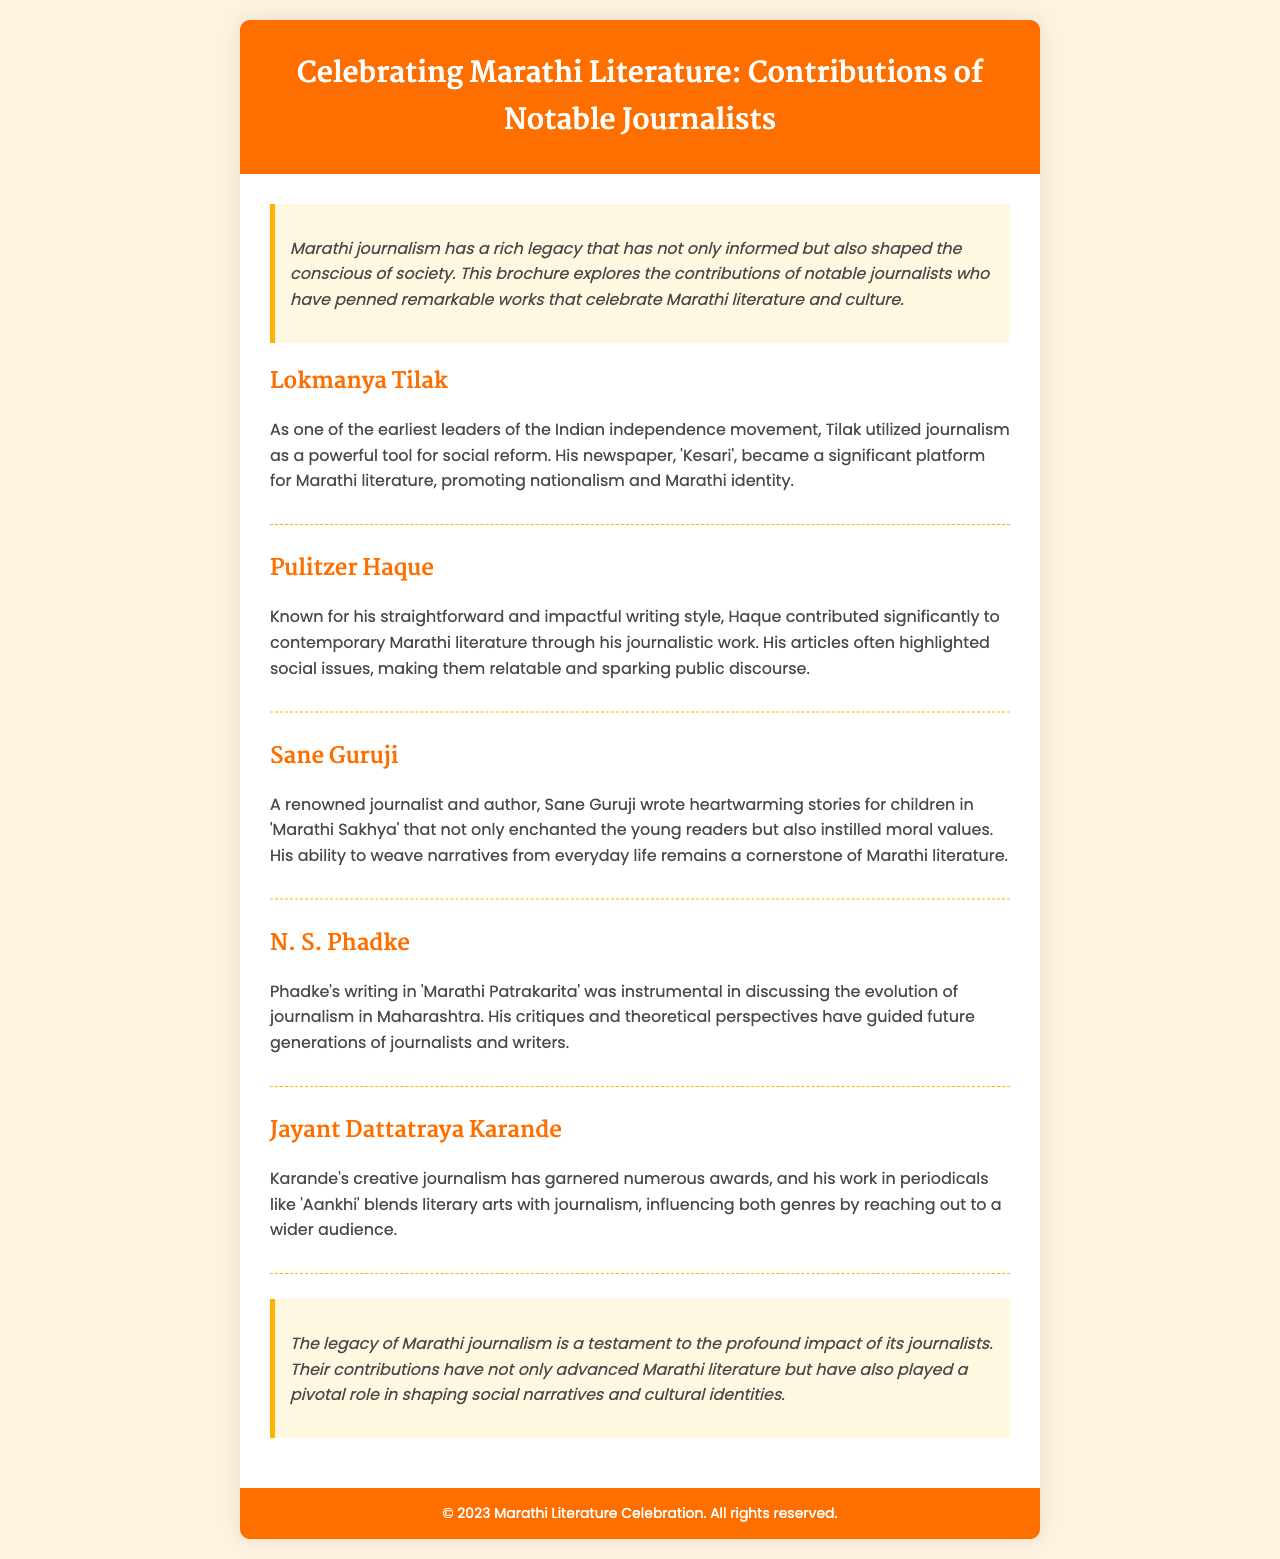What is the title of the brochure? The title is clearly mentioned at the top of the document.
Answer: Celebrating Marathi Literature: Contributions of Notable Journalists Who was the editor of the newspaper 'Kesari'? The document mentions Lokmanya Tilak as the editor of 'Kesari'.
Answer: Lokmanya Tilak Which journalist is known for writing stories for children? The document states that Sane Guruji wrote heartwarming stories for children.
Answer: Sane Guruji What type of writing is Pulitzer Haque known for? The document describes Haque's style as straightforward and impactful.
Answer: Straightforward and impactful In which publication did N. S. Phadke discuss the evolution of journalism? The document specifies Phadke's writing was in 'Marathi Patrakarita'.
Answer: Marathi Patrakarita Which journalist blended literary arts with journalism? The document mentions Jayant Dattatraya Karande for this blending of genres.
Answer: Jayant Dattatraya Karande What common theme do the contributions of these journalists share? The document describes their collective effort in shaping social narratives and cultural identities.
Answer: Shaping social narratives and cultural identities What year is mentioned in the footer of the document? The footer specifies a year for copyrights related to the document.
Answer: 2023 